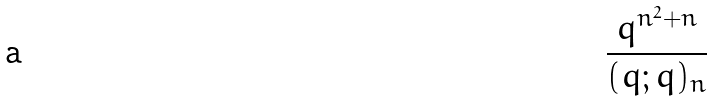<formula> <loc_0><loc_0><loc_500><loc_500>\frac { q ^ { n ^ { 2 } + n } } { ( q ; q ) _ { n } }</formula> 